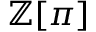Convert formula to latex. <formula><loc_0><loc_0><loc_500><loc_500>\mathbb { Z } [ \pi ]</formula> 